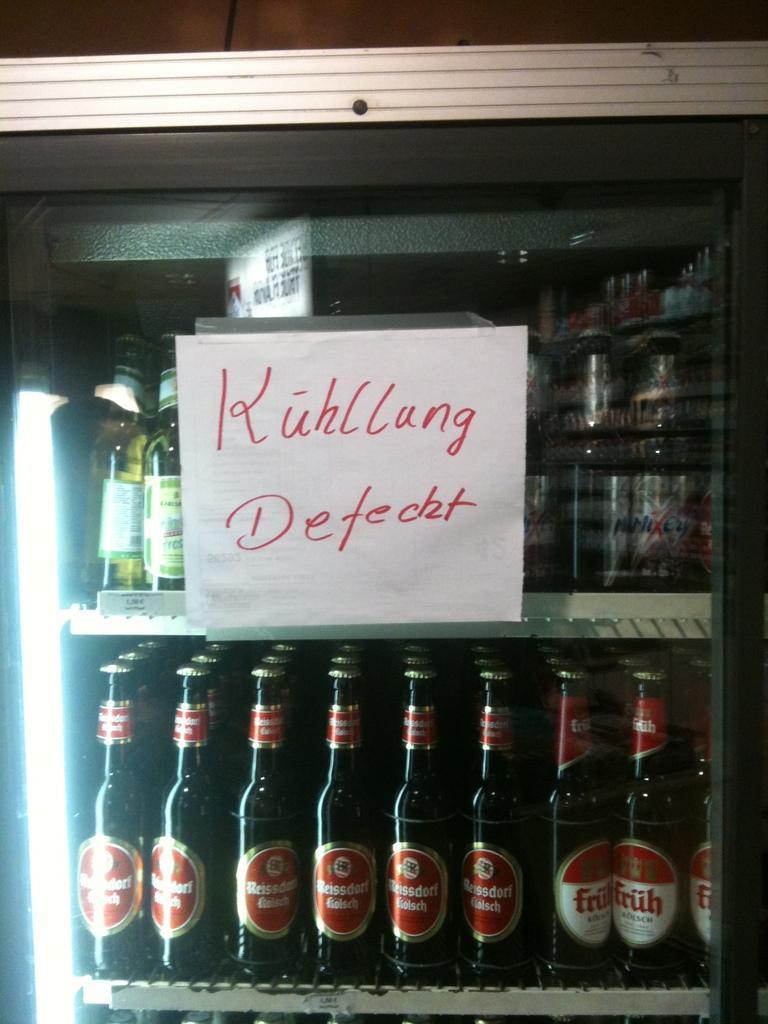Describe this image in one or two sentences. In this image there is a refrigerator. Inside the refrigerator there are many bottles placed. On the glass of the refrigerator this is a paper sticked with text "Khullung Defetchh" on it. 